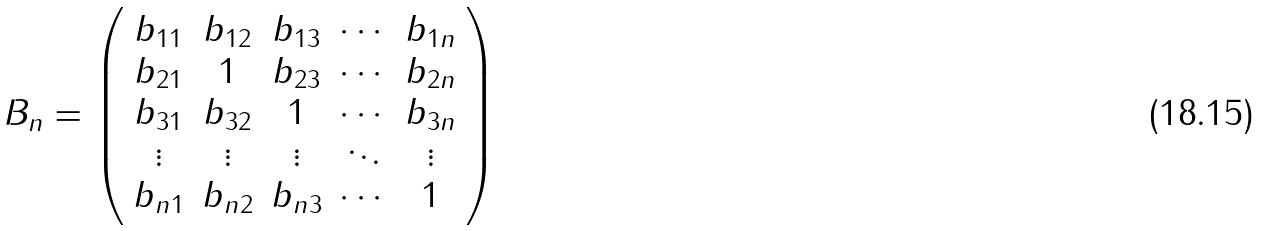<formula> <loc_0><loc_0><loc_500><loc_500>B _ { n } = \left ( \begin{array} { c c c c c } b _ { 1 1 } & b _ { 1 2 } & b _ { 1 3 } & \cdots & b _ { 1 n } \\ b _ { 2 1 } & 1 & b _ { 2 3 } & \cdots & b _ { 2 n } \\ b _ { 3 1 } & b _ { 3 2 } & 1 & \cdots & b _ { 3 n } \\ \vdots & \vdots & \vdots & \ddots & \vdots \\ b _ { n 1 } & b _ { n 2 } & b _ { n 3 } & \cdots & 1 \\ \end{array} \right )</formula> 